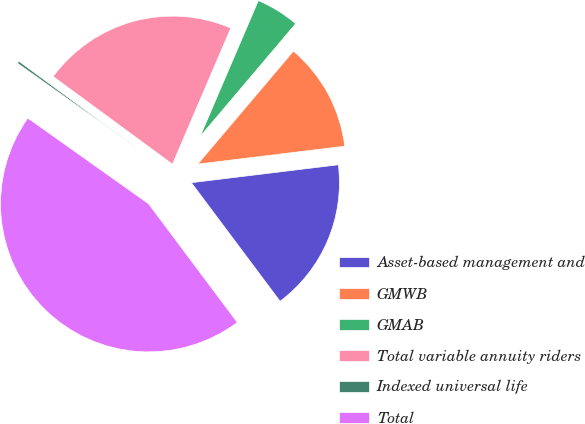Convert chart. <chart><loc_0><loc_0><loc_500><loc_500><pie_chart><fcel>Asset-based management and<fcel>GMWB<fcel>GMAB<fcel>Total variable annuity riders<fcel>Indexed universal life<fcel>Total<nl><fcel>16.71%<fcel>11.89%<fcel>4.74%<fcel>21.36%<fcel>0.26%<fcel>45.05%<nl></chart> 